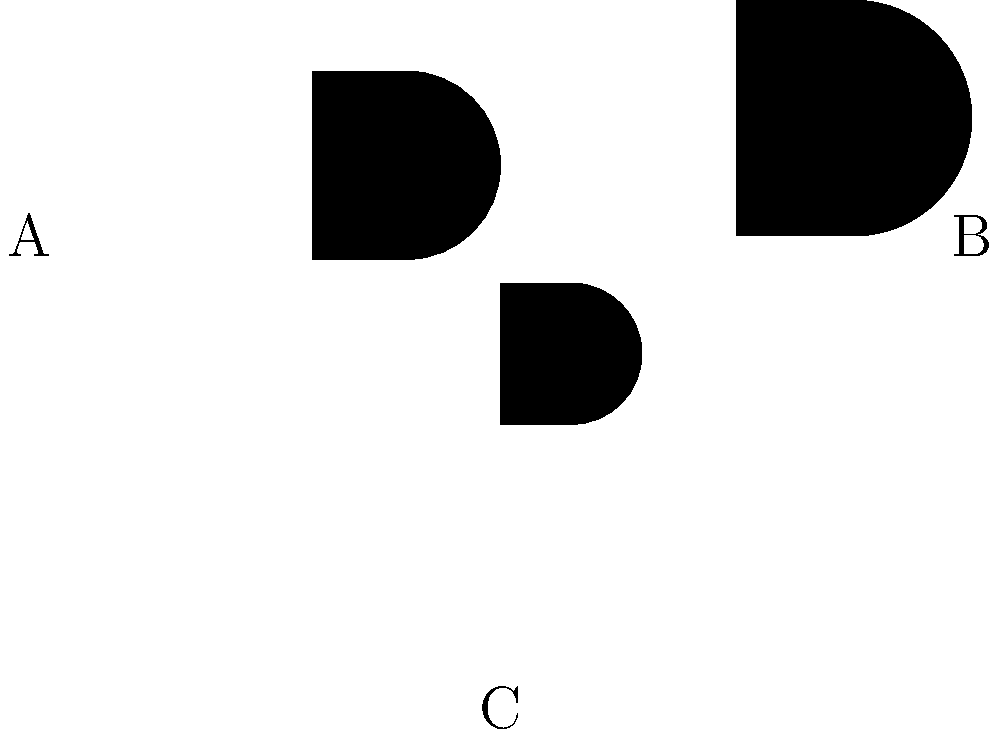Which of the bird silhouettes shown above most likely represents the Red Grouse, a native species of Yorkshire known for its distinctive shape and importance to the region's moorland ecosystems? To identify the Red Grouse from the silhouettes, let's consider the following steps:

1. Red Grouse characteristics:
   - Medium-sized game bird
   - Plump body
   - Short tail
   - Rounded wings

2. Analyzing the silhouettes:
   A: Larger bird with a longer neck and tail, not typical of Red Grouse
   B: Medium-sized bird with a plump body and short tail, matching Red Grouse description
   C: Smaller bird with a less rounded body shape, not consistent with Red Grouse

3. Ecological context:
   - Red Grouse is closely associated with Yorkshire's moorland habitats
   - Its shape is adapted for ground-dwelling in heather moorlands

4. Cultural significance:
   - Red Grouse is an iconic species in Yorkshire, important for conservation and local traditions

Based on these considerations, silhouette B most closely resembles the characteristics of a Red Grouse, with its plump body shape and short tail typical of this species found in Yorkshire's moorlands.
Answer: B 